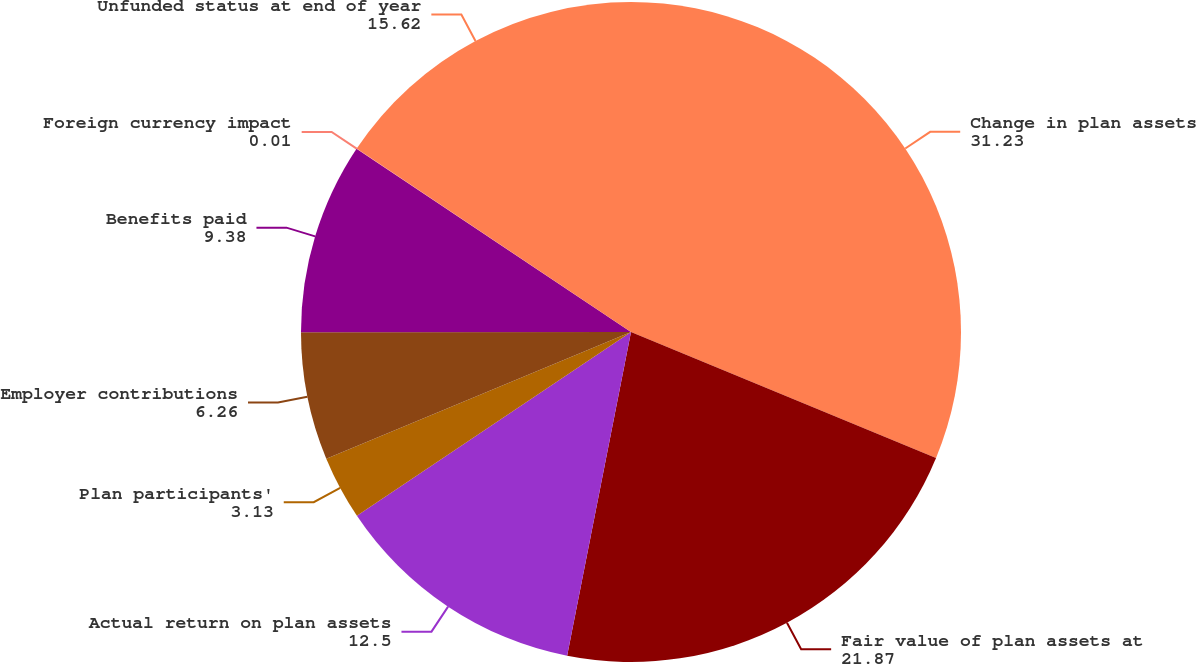Convert chart to OTSL. <chart><loc_0><loc_0><loc_500><loc_500><pie_chart><fcel>Change in plan assets<fcel>Fair value of plan assets at<fcel>Actual return on plan assets<fcel>Plan participants'<fcel>Employer contributions<fcel>Benefits paid<fcel>Foreign currency impact<fcel>Unfunded status at end of year<nl><fcel>31.23%<fcel>21.87%<fcel>12.5%<fcel>3.13%<fcel>6.26%<fcel>9.38%<fcel>0.01%<fcel>15.62%<nl></chart> 